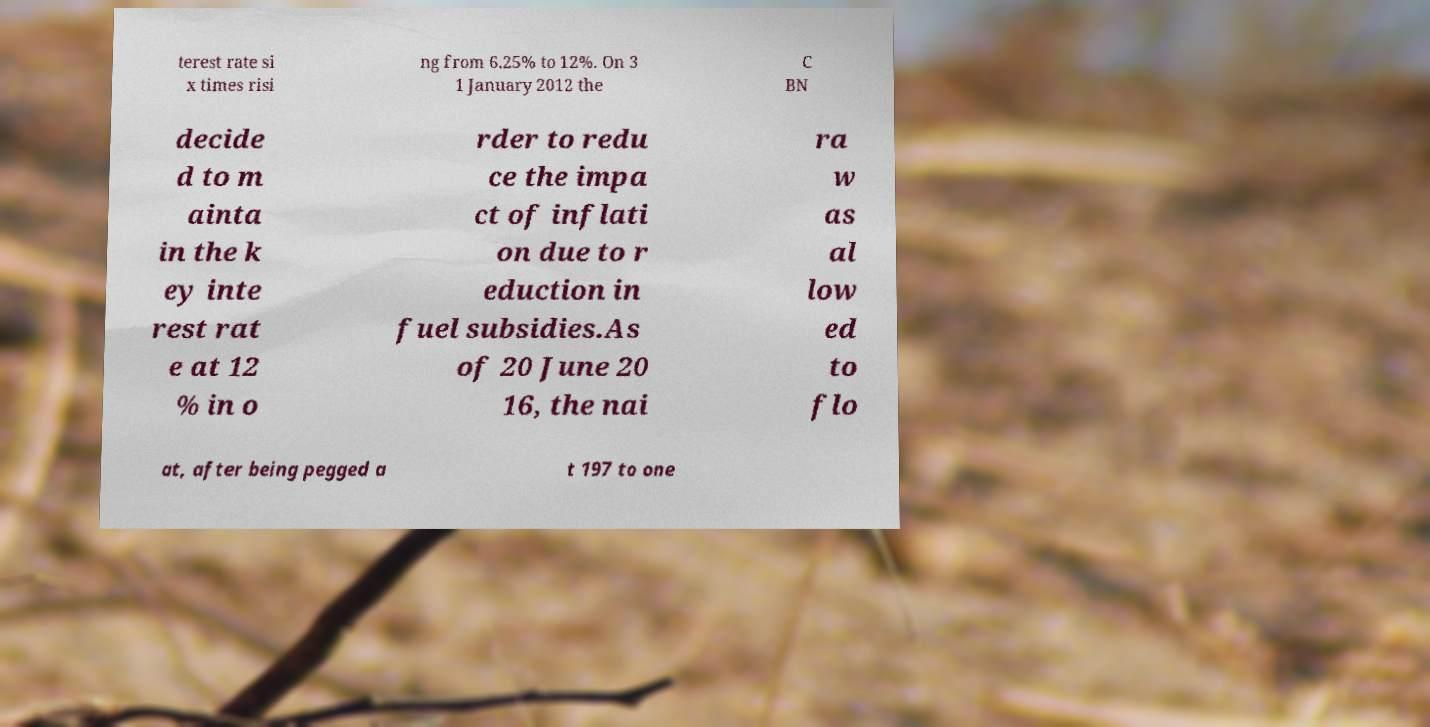Can you read and provide the text displayed in the image?This photo seems to have some interesting text. Can you extract and type it out for me? terest rate si x times risi ng from 6.25% to 12%. On 3 1 January 2012 the C BN decide d to m ainta in the k ey inte rest rat e at 12 % in o rder to redu ce the impa ct of inflati on due to r eduction in fuel subsidies.As of 20 June 20 16, the nai ra w as al low ed to flo at, after being pegged a t 197 to one 